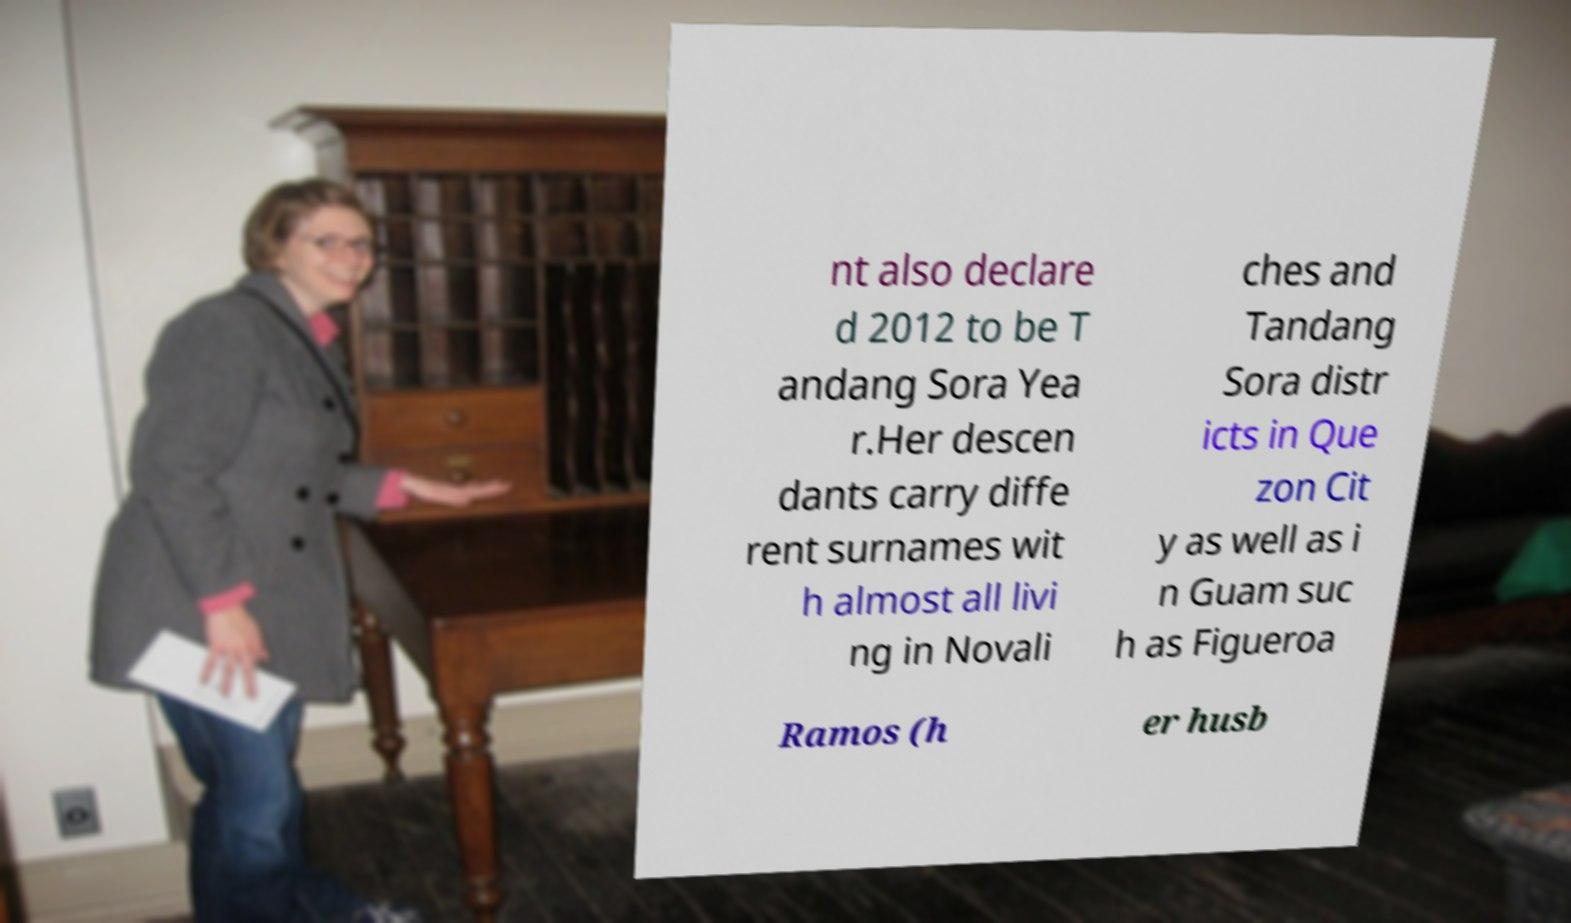Could you extract and type out the text from this image? nt also declare d 2012 to be T andang Sora Yea r.Her descen dants carry diffe rent surnames wit h almost all livi ng in Novali ches and Tandang Sora distr icts in Que zon Cit y as well as i n Guam suc h as Figueroa Ramos (h er husb 